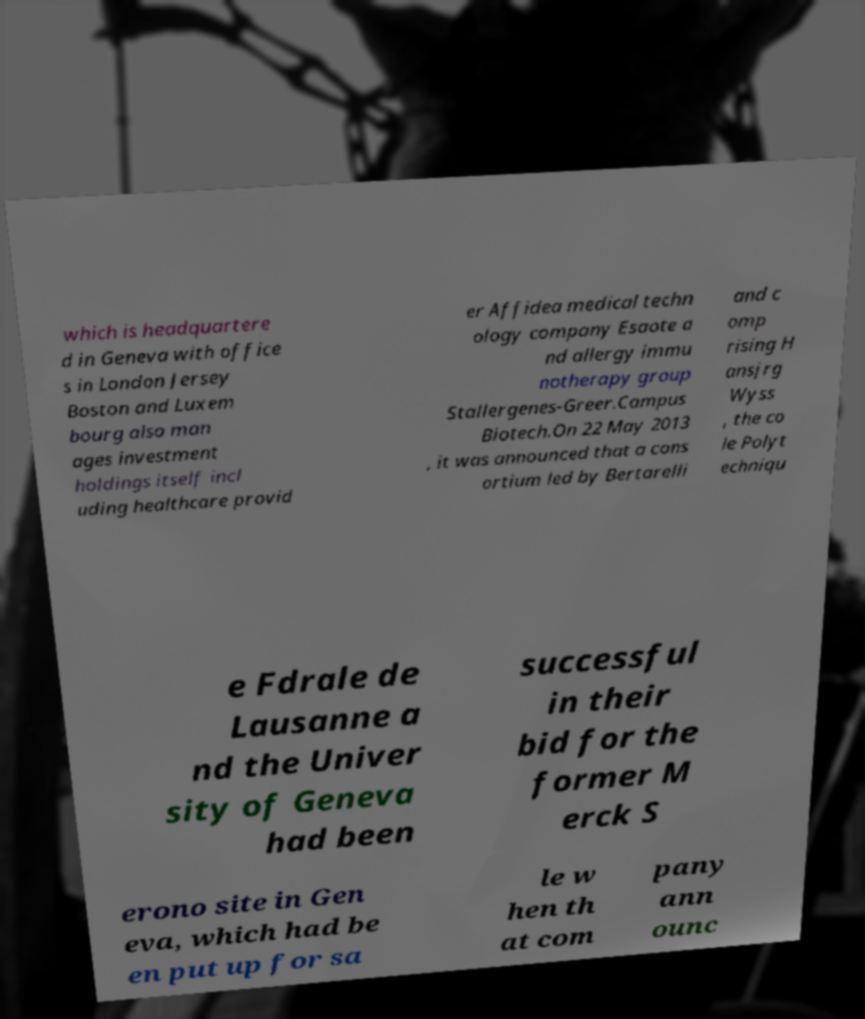Can you accurately transcribe the text from the provided image for me? which is headquartere d in Geneva with office s in London Jersey Boston and Luxem bourg also man ages investment holdings itself incl uding healthcare provid er Affidea medical techn ology company Esaote a nd allergy immu notherapy group Stallergenes-Greer.Campus Biotech.On 22 May 2013 , it was announced that a cons ortium led by Bertarelli and c omp rising H ansjrg Wyss , the co le Polyt echniqu e Fdrale de Lausanne a nd the Univer sity of Geneva had been successful in their bid for the former M erck S erono site in Gen eva, which had be en put up for sa le w hen th at com pany ann ounc 